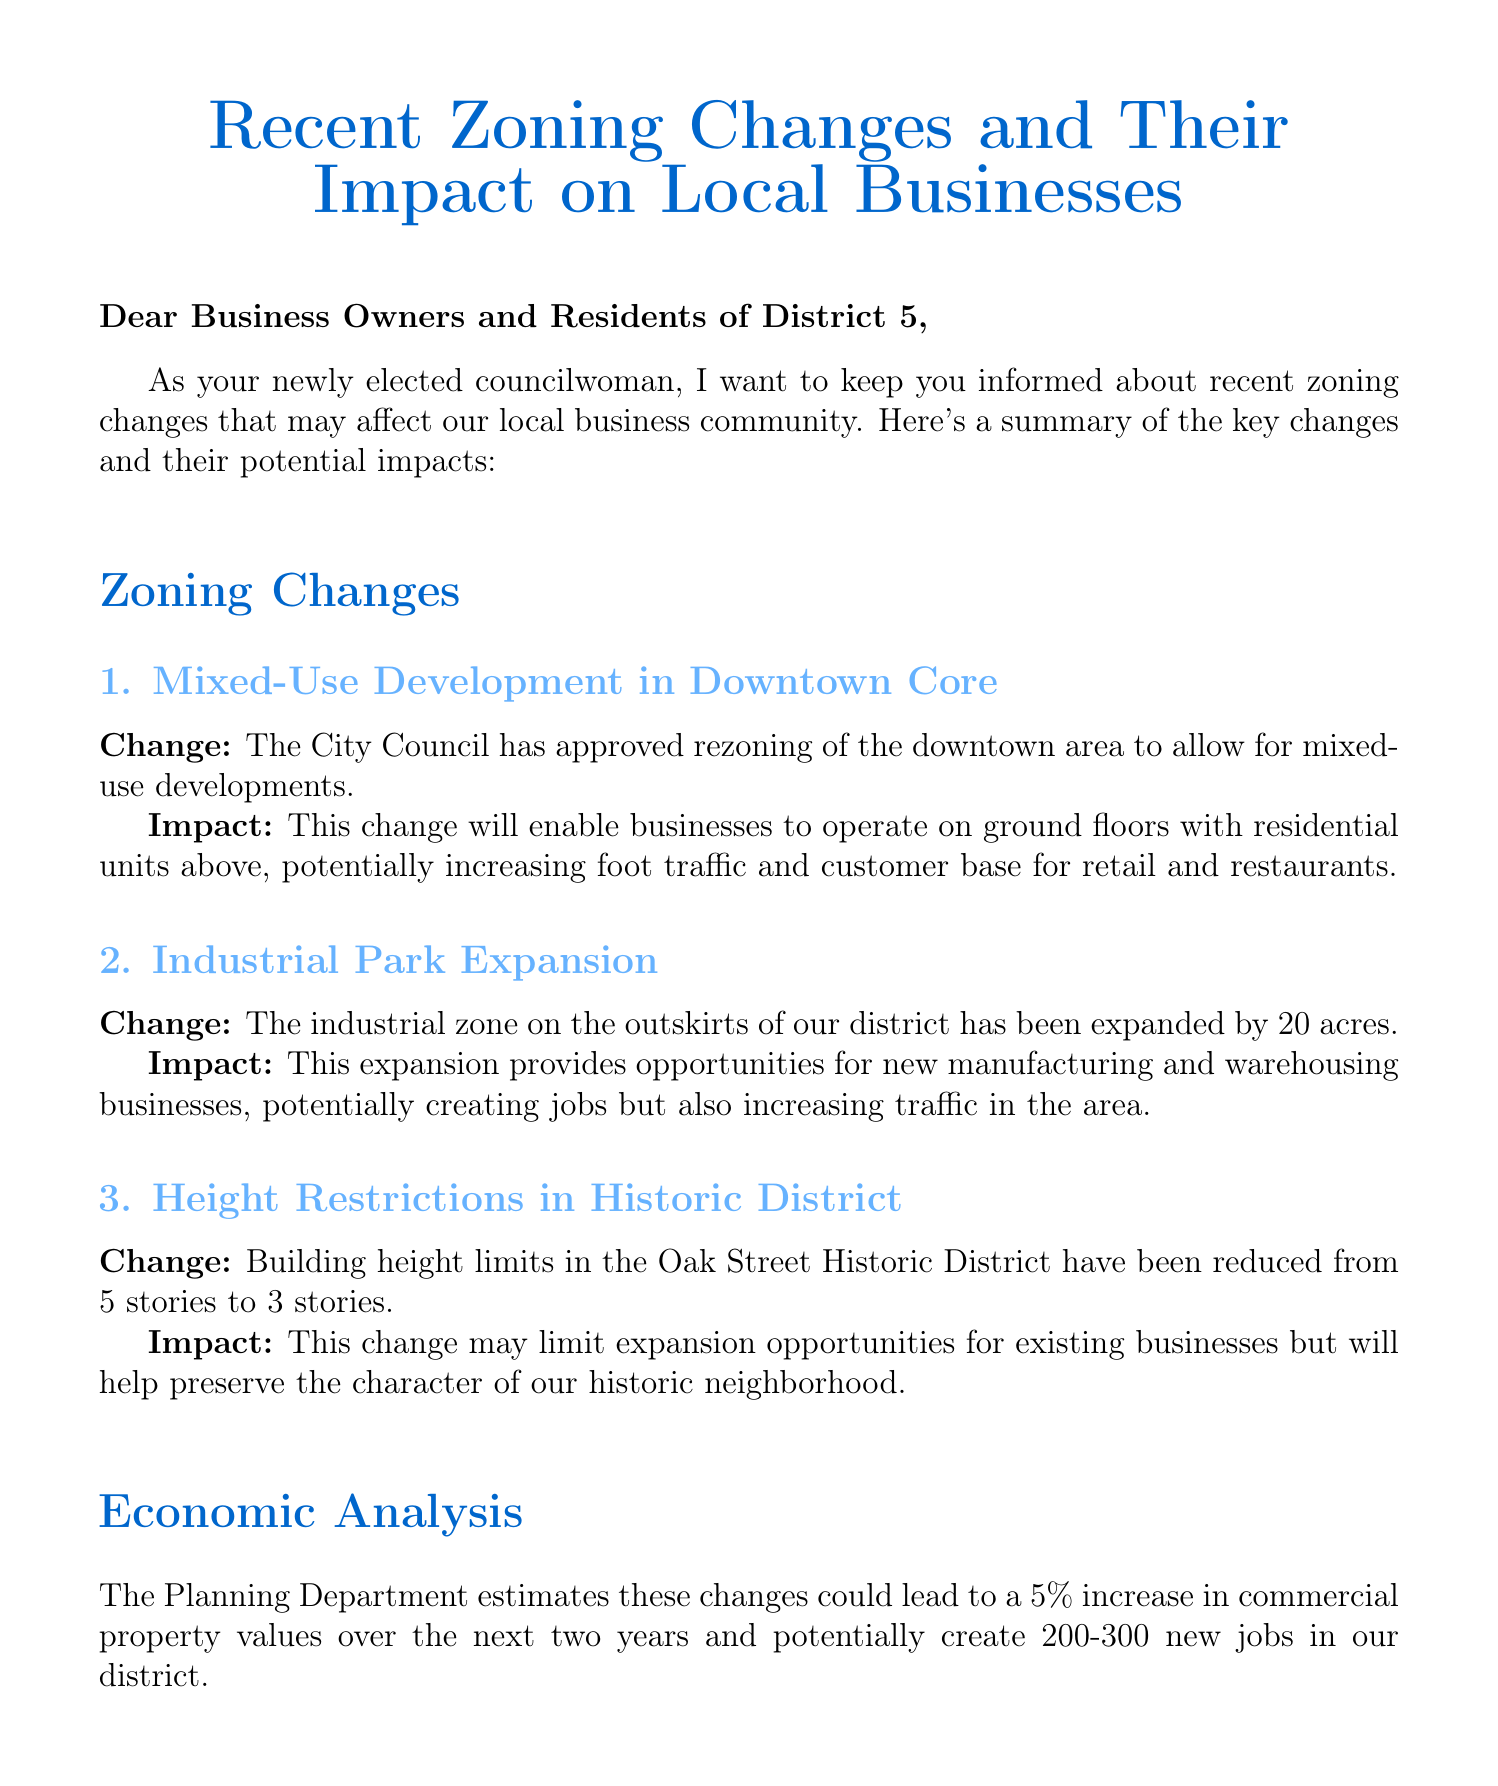what are the recent zoning changes? The document lists three recent zoning changes: Mixed-Use Development in Downtown Core, Industrial Park Expansion, and Height Restrictions in Historic District.
Answer: Mixed-Use Development, Industrial Park Expansion, Height Restrictions what is the date of the community meeting? The community meeting is scheduled for May 15th at 7 PM, as stated in the document.
Answer: May 15th how many acres has the industrial park expanded? The document mentions that the industrial park has been expanded by 20 acres.
Answer: 20 acres what is the estimated percentage increase in commercial property values? The Planning Department estimates a 5% increase in commercial property values over the next two years.
Answer: 5% who is hosting the community meeting? The community meeting is hosted by Councilwoman Sarah Johnson, as indicated in the signing section of the document.
Answer: Councilwoman Sarah Johnson what is one potential effect of the height restriction change? The height restriction change may limit expansion opportunities for existing businesses but will help preserve the character of the neighborhood, as stated in the impact analysis.
Answer: Limit expansion opportunities how many new jobs could potentially be created in the district? The document states that the changes could potentially create 200-300 new jobs in the district.
Answer: 200-300 jobs what is the purpose of the email? The purpose is to inform local business owners and residents about recent zoning changes affecting their community.
Answer: To inform about zoning changes 